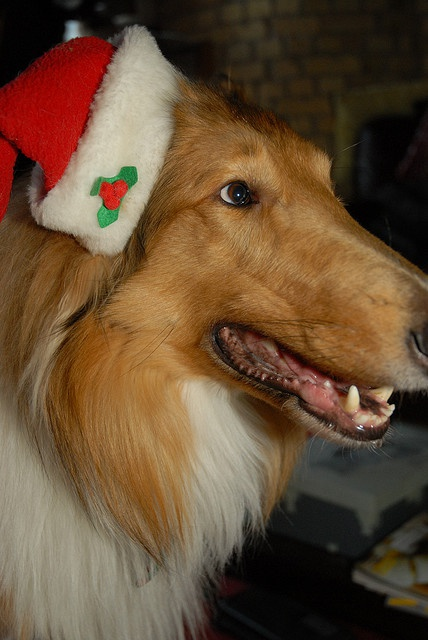Describe the objects in this image and their specific colors. I can see a dog in black, olive, maroon, tan, and gray tones in this image. 